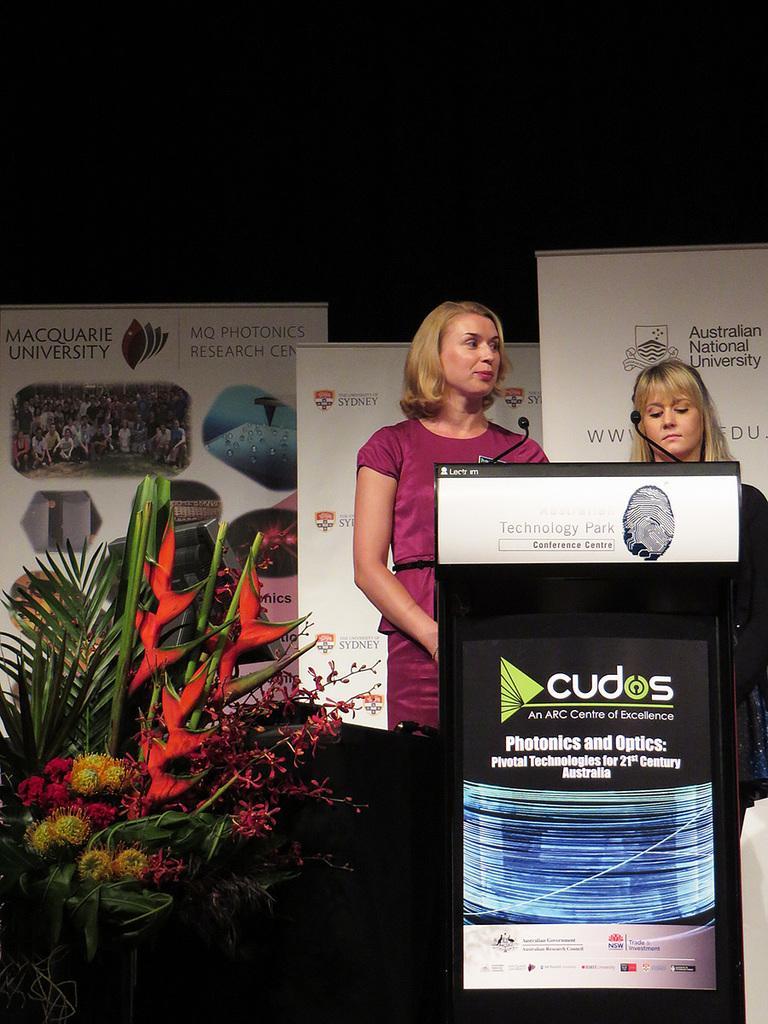In one or two sentences, can you explain what this image depicts? In this picture we can observe two women standing near the podium. We can observe two mics in front of them. One of the woman is wearing a pink color dress. We can observe bouquet on the left side. In the background there are some white color posters. 